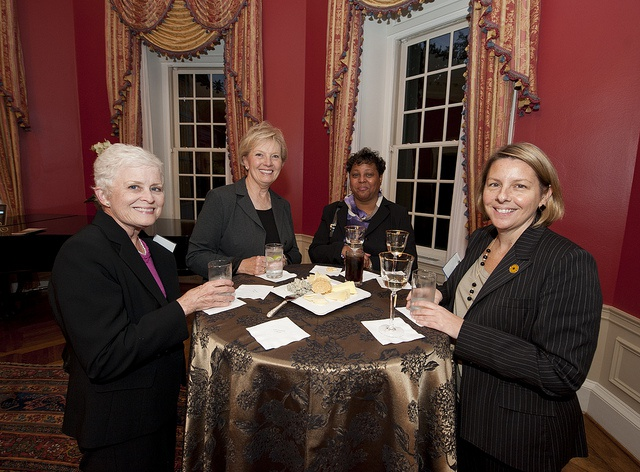Describe the objects in this image and their specific colors. I can see people in maroon, black, tan, and gray tones, people in maroon, black, tan, gray, and lightgray tones, dining table in maroon, black, and white tones, people in maroon, black, gray, and tan tones, and people in maroon, black, and brown tones in this image. 